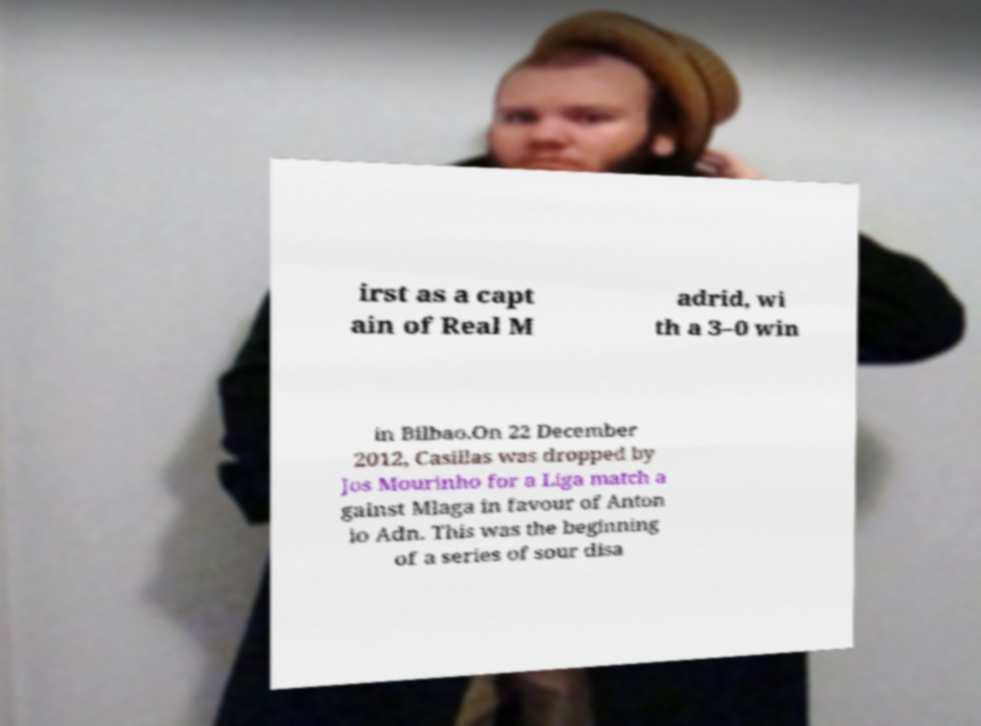Can you accurately transcribe the text from the provided image for me? irst as a capt ain of Real M adrid, wi th a 3–0 win in Bilbao.On 22 December 2012, Casillas was dropped by Jos Mourinho for a Liga match a gainst Mlaga in favour of Anton io Adn. This was the beginning of a series of sour disa 